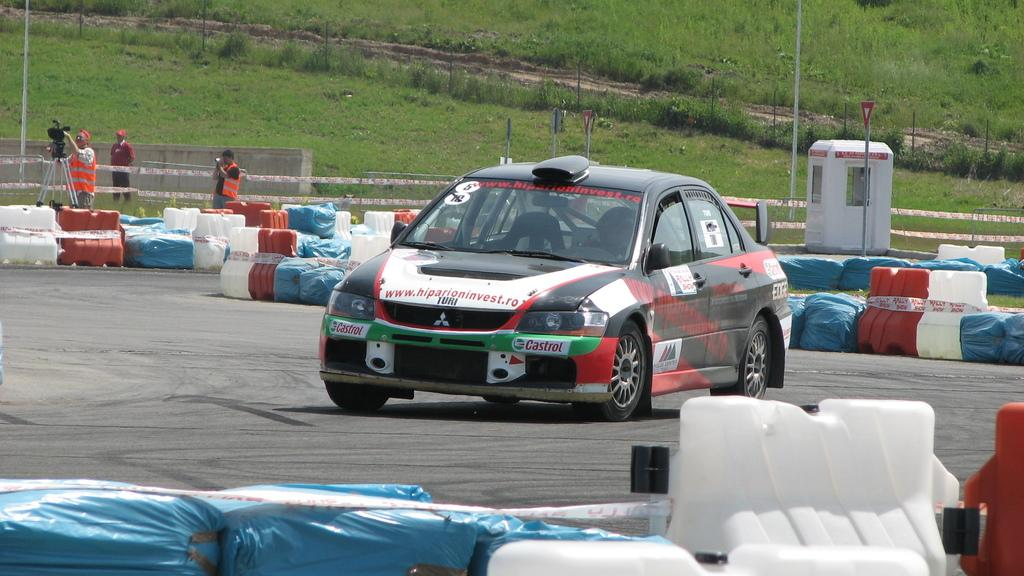What is the main subject of the image? The main subject of the image is a car. Can you describe the color of the car? The car is black and red in color. What else can be seen on the left side of the image? There are three men standing on the left side of the image. What type of vegetation is in the middle of the image? There is grass in the middle of the image. What type of coastline can be seen in the image? There is no coastline present in the image; it features a car, men, and grass. Is there any evidence of a war taking place in the image? There is no indication of a war or any conflict in the image. 